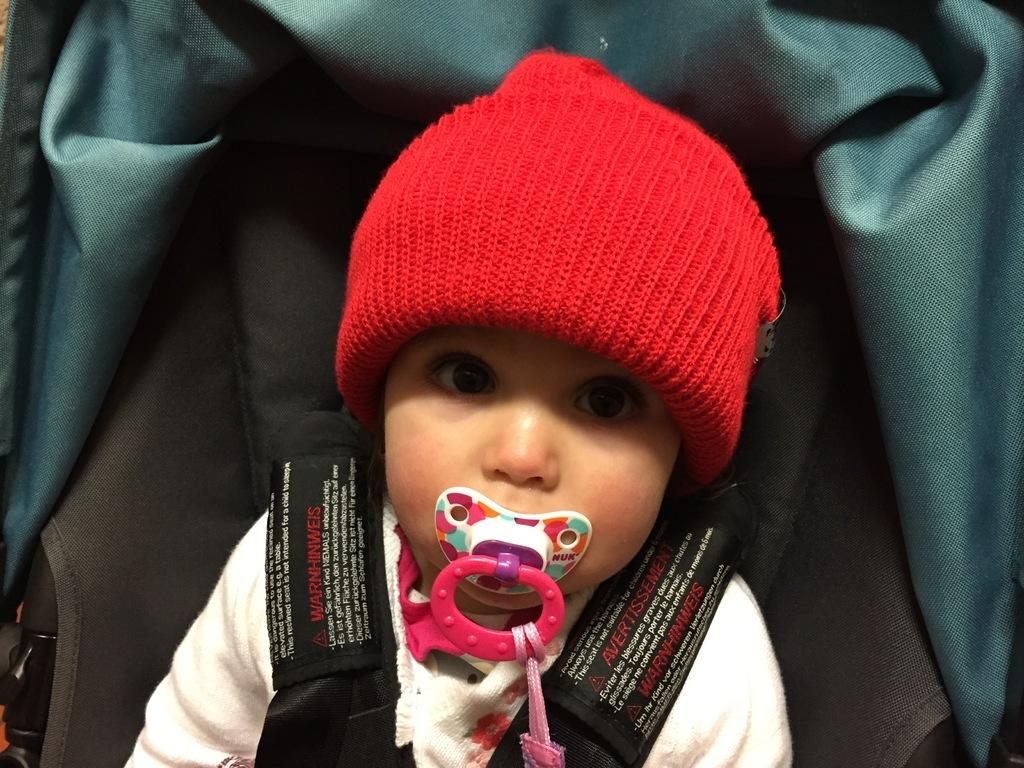What is the main subject of the image? There is a baby in the image. What is the baby wearing on their head? The baby is wearing a cap. What is the baby doing with the object in their mouth? There is an object in the baby's mouth, but we cannot determine the action from the image. What can be seen in the background of the image? There is a chair in the background of the image. Can you see any zippers on the baby's clothing in the image? There is no mention of a zipper on the baby's clothing in the provided facts, so we cannot determine its presence from the image. What type of ocean can be seen in the background of the image? There is no ocean present in the image; it features a baby and a chair in the background. 